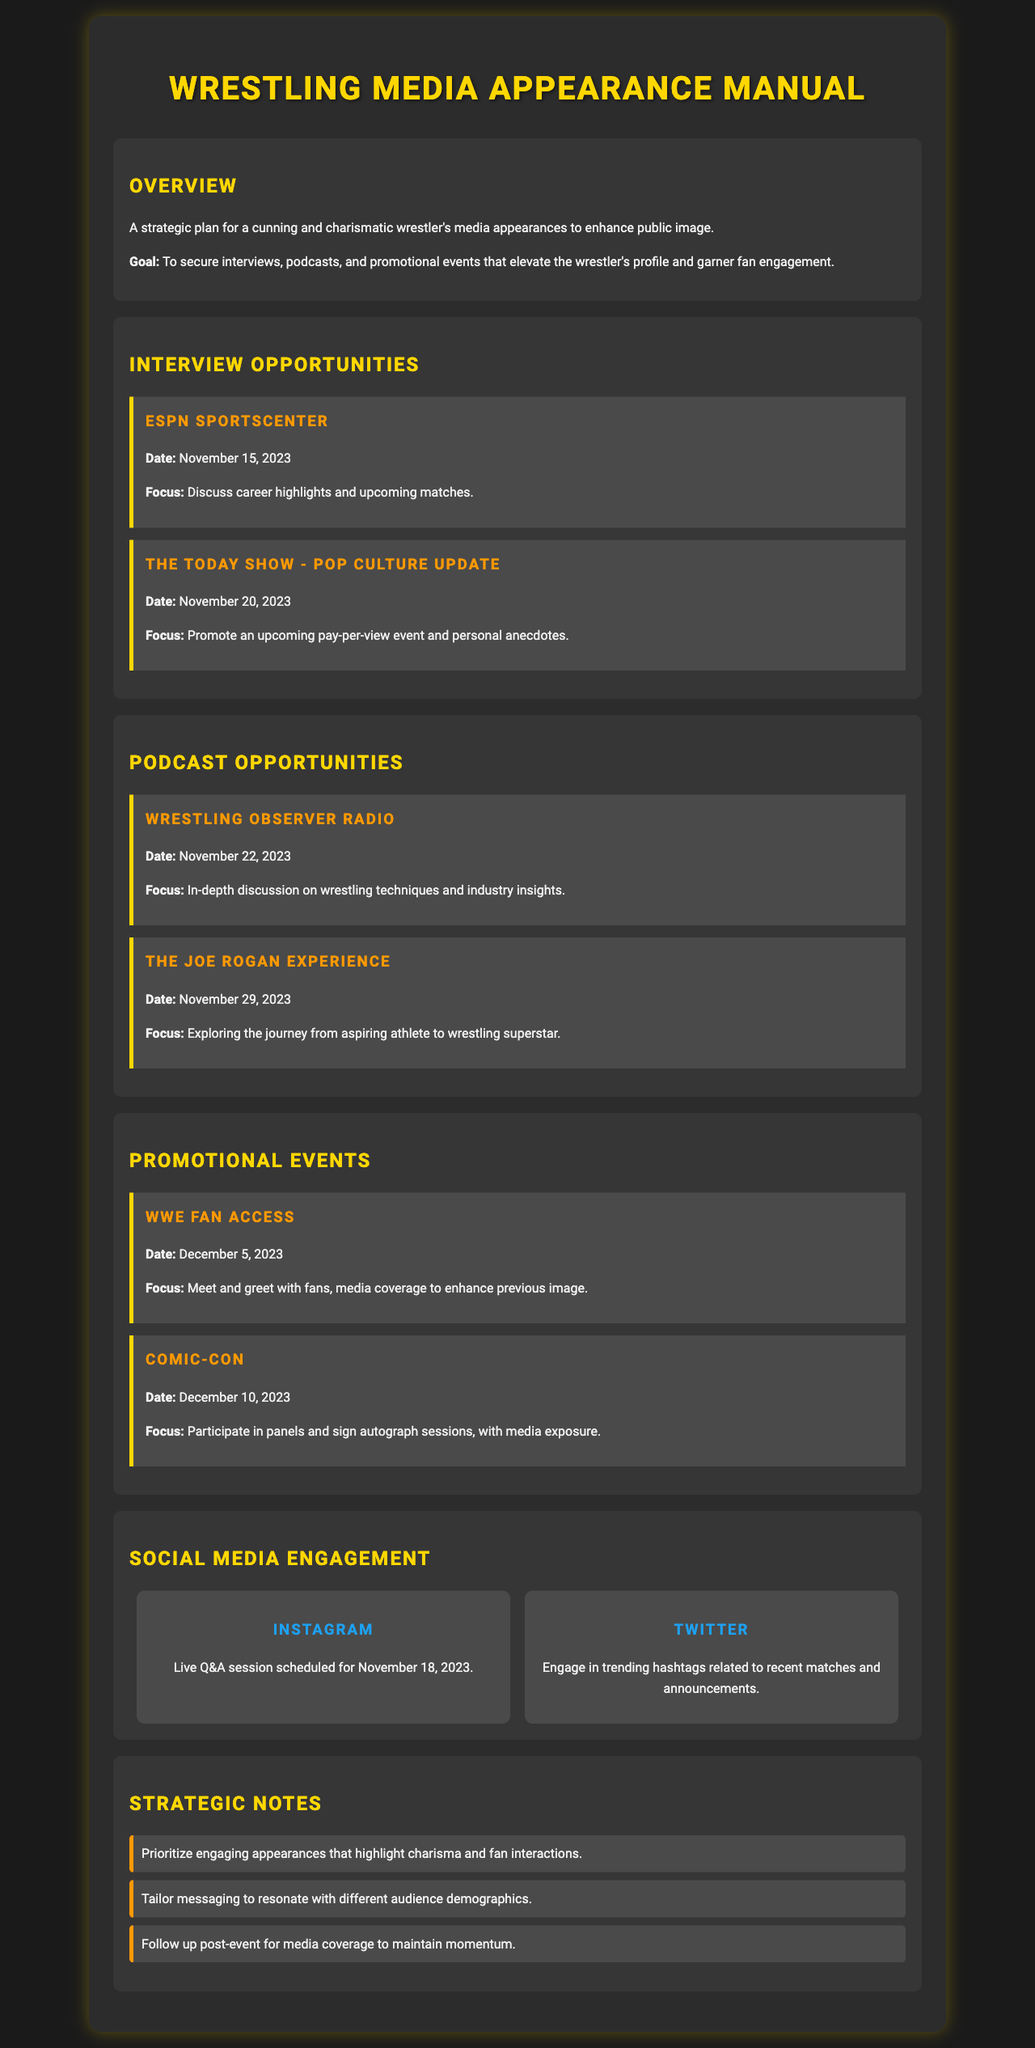what is the primary goal of the media appearance plan? The goal is to secure interviews, podcasts, and promotional events that elevate the wrestler's profile and garner fan engagement.
Answer: To secure interviews, podcasts, and promotional events that elevate the wrestler's profile and garner fan engagement when is the interview with ESPN SportsCenter scheduled? The date provided in the document for the interview with ESPN SportsCenter is November 15, 2023.
Answer: November 15, 2023 what focus will be discussed on The Today Show? The focus is to promote an upcoming pay-per-view event and personal anecdotes.
Answer: Promote an upcoming pay-per-view event and personal anecdotes how many promotional events are listed in the document? The document lists a total of two promotional events during the given timeline.
Answer: Two which podcast features an in-depth discussion on wrestling techniques? The podcast that features this discussion is Wrestling Observer Radio.
Answer: Wrestling Observer Radio what social media engagement is scheduled for November 18, 2023? A live Q&A session on Instagram is scheduled for this date.
Answer: Live Q&A session on Instagram what is a strategic note regarding media appearances? One of the strategic notes is to prioritize engaging appearances that highlight charisma and fan interactions.
Answer: Prioritize engaging appearances that highlight charisma and fan interactions what type of event is WWE Fan Access? It is a meet and greet with fans, including media coverage.
Answer: Meet and greet with fans, media coverage what is the date of the podcast The Joe Rogan Experience? The date listed for this podcast is November 29, 2023.
Answer: November 29, 2023 